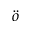<formula> <loc_0><loc_0><loc_500><loc_500>\ddot { o }</formula> 